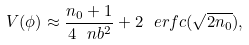<formula> <loc_0><loc_0><loc_500><loc_500>V ( \phi ) \approx \frac { n _ { 0 } + 1 } { 4 \ n b ^ { 2 } } + 2 \ e r f c ( \sqrt { 2 n _ { 0 } } ) ,</formula> 